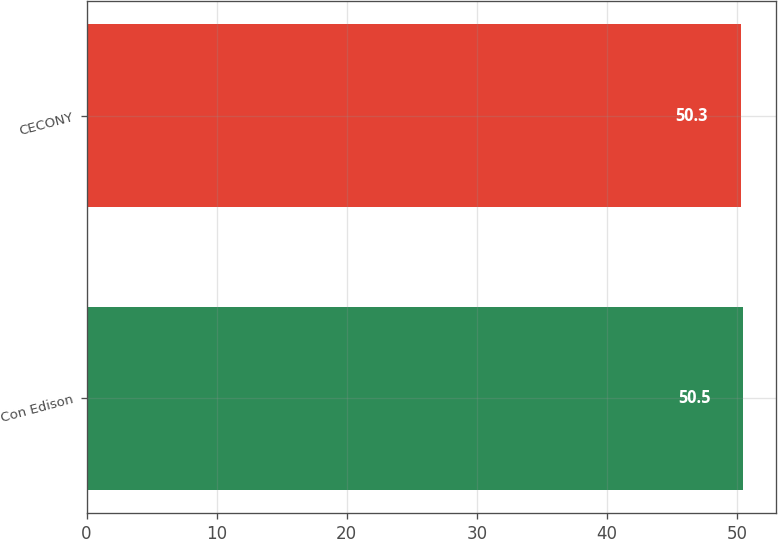Convert chart to OTSL. <chart><loc_0><loc_0><loc_500><loc_500><bar_chart><fcel>Con Edison<fcel>CECONY<nl><fcel>50.5<fcel>50.3<nl></chart> 